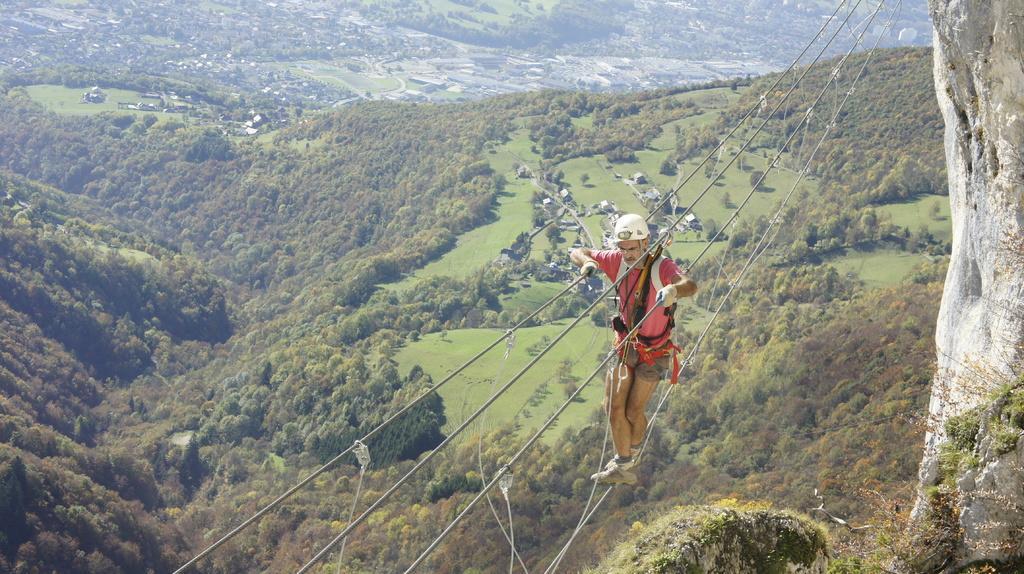How would you summarize this image in a sentence or two? The man in the middle of the picture wearing red T-shirt and white helmet is either abseiling or rope walking. In the background, there are many trees. On the right side, we see a rock. 